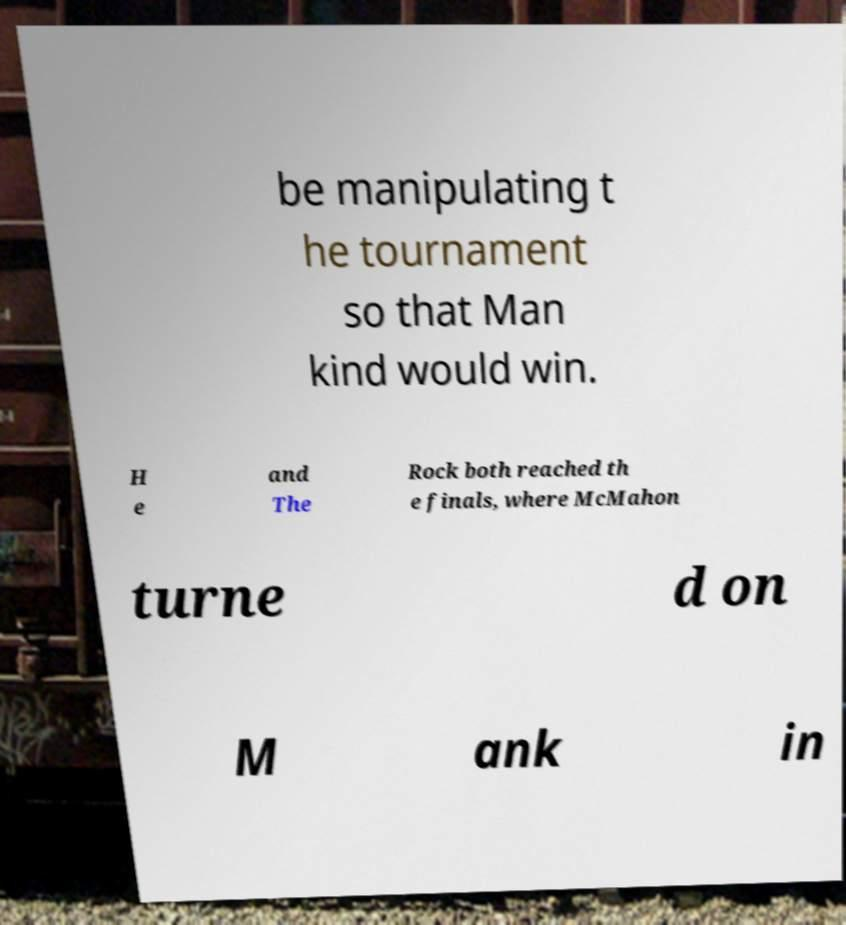Please identify and transcribe the text found in this image. be manipulating t he tournament so that Man kind would win. H e and The Rock both reached th e finals, where McMahon turne d on M ank in 